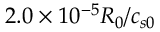<formula> <loc_0><loc_0><loc_500><loc_500>2 . 0 \times 1 0 ^ { - 5 } R _ { 0 } / c _ { s 0 }</formula> 